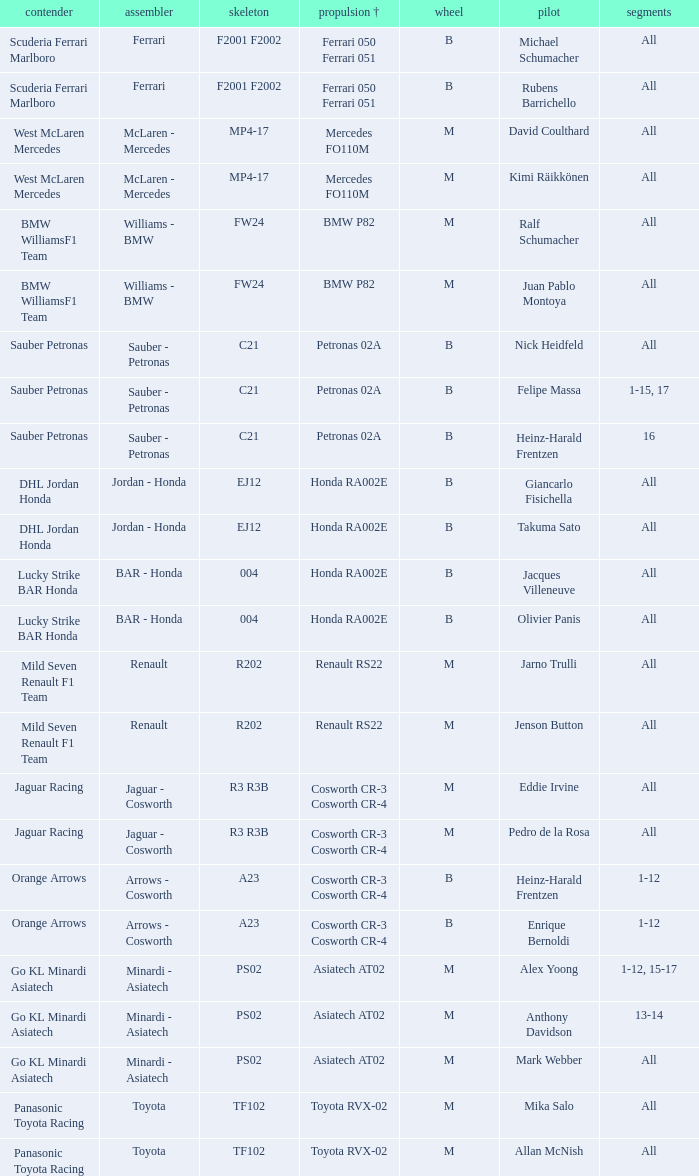Who is the entrant when the engine is bmw p82? BMW WilliamsF1 Team, BMW WilliamsF1 Team. 